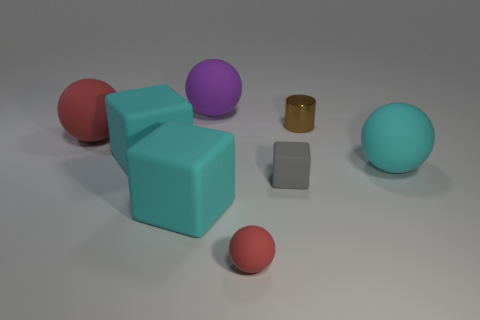What is the size of the cyan sphere that is made of the same material as the large purple object?
Give a very brief answer. Large. Is there a matte ball of the same color as the tiny block?
Your response must be concise. No. Does the purple rubber ball have the same size as the sphere to the right of the metal object?
Your answer should be very brief. Yes. There is a cyan thing that is behind the large cyan matte object that is on the right side of the big purple rubber ball; what number of balls are right of it?
Keep it short and to the point. 3. What size is the thing that is the same color as the small rubber ball?
Make the answer very short. Large. There is a brown cylinder; are there any large objects right of it?
Provide a succinct answer. Yes. There is a gray matte thing; what shape is it?
Give a very brief answer. Cube. The red thing that is right of the matte sphere behind the red object on the left side of the purple matte object is what shape?
Your answer should be very brief. Sphere. How many other objects are there of the same shape as the small gray matte object?
Your answer should be compact. 2. What is the material of the large cyan thing that is to the right of the large thing that is in front of the gray thing?
Ensure brevity in your answer.  Rubber. 